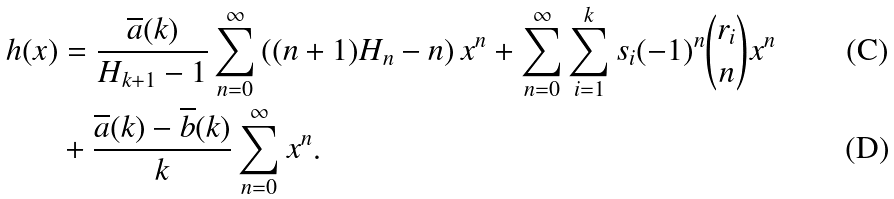Convert formula to latex. <formula><loc_0><loc_0><loc_500><loc_500>h ( x ) & = \frac { \overline { a } ( k ) } { H _ { k + 1 } - 1 } \sum _ { n = 0 } ^ { \infty } \left ( ( n + 1 ) H _ { n } - n \right ) x ^ { n } + \sum _ { n = 0 } ^ { \infty } \sum _ { i = 1 } ^ { k } s _ { i } ( - 1 ) ^ { n } \binom { r _ { i } } { n } x ^ { n } \\ & + \frac { \overline { a } ( k ) - \overline { b } ( k ) } { k } \sum _ { n = 0 } ^ { \infty } x ^ { n } .</formula> 